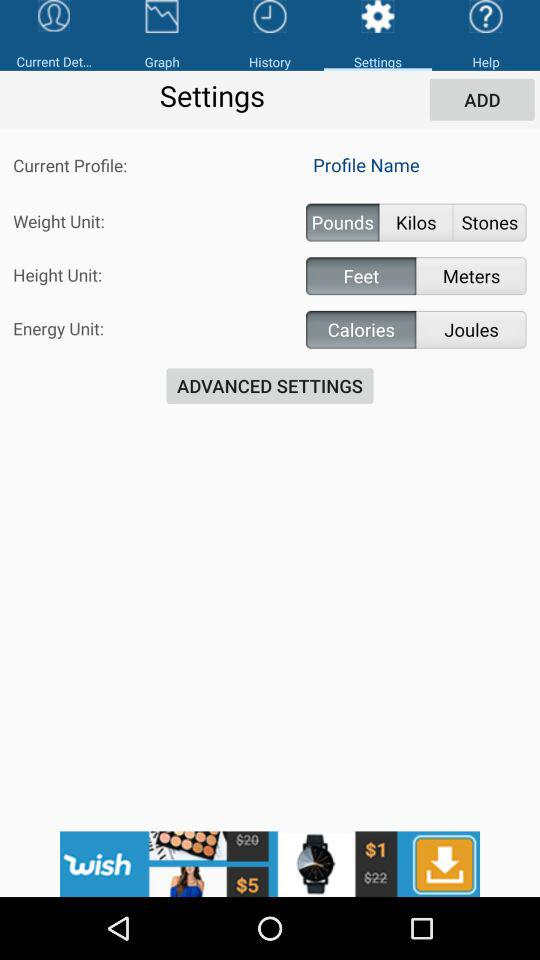What is the height unit? The height unit is feet. 